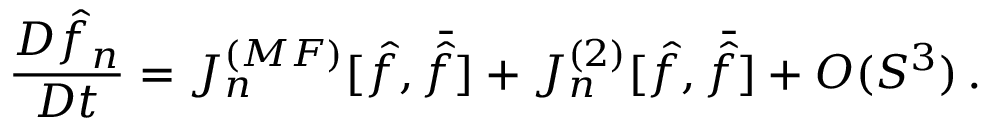<formula> <loc_0><loc_0><loc_500><loc_500>{ \frac { D \hat { f } _ { n } } { D t } } = J _ { n } ^ { ( M F ) } [ \hat { f } , \bar { \hat { f } } ] + J _ { n } ^ { ( 2 ) } [ \hat { f } , \bar { \hat { f } } ] + O ( S ^ { 3 } ) \, .</formula> 